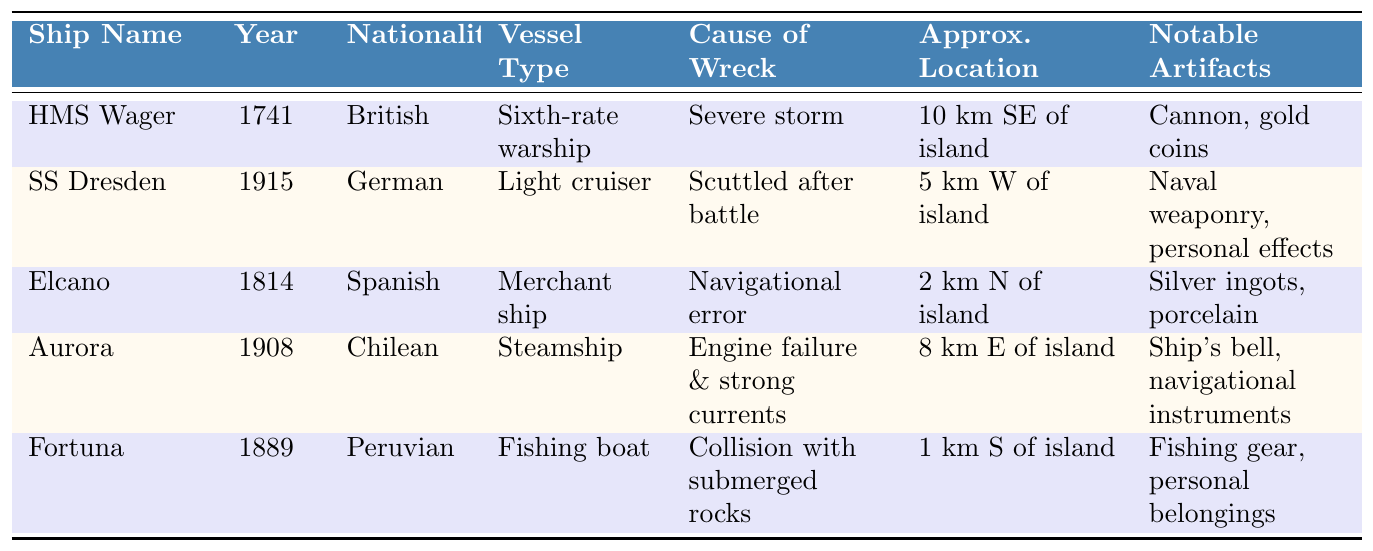What is the nationality of HMS Wager? HMS Wager is listed in the table, and under the "Nationality" column, it states "British."
Answer: British In which year did the SS Dresden sink? Looking at the table, the "Year of Wreck" column for SS Dresden indicates 1915.
Answer: 1915 What caused the wreck of the Aurora? The table shows that the "Cause of Wreck" for the Aurora is "Engine failure and strong currents."
Answer: Engine failure and strong currents Which shipwreck occurred closest to Alejandro Selkirk Island? By checking the "Approximate Location" column, Fortuna is noted as being wrecked 1 km south of the island, which is the nearest distance.
Answer: Fortuna What notable artifacts were found from the ship Elcano? The table indicates that "Silver ingots, porcelain" were notable artifacts found from Elcano.
Answer: Silver ingots, porcelain How many shipwrecks listed in the table occurred in the 19th century? The table identifies three shipwrecks occurring between 1800 and 1899: Elcano (1814), Fortuna (1889), and Aurora (1908 is in the 20th century). Thus, there are three shipwrecks in the 19th century.
Answer: Three Which ship was scuttled after a battle? SS Dresden is specified in the table with the cause of wreck being "Scuttled after battle."
Answer: SS Dresden Is there any German shipwreck listed in the table? Reviewing the table, the SS Dresden is noted as a German shipwreck, confirming the presence of a German vessel.
Answer: Yes What is the average year of wreck for the vessels listed? To find the average, sum the years of wreck (1741 + 1915 + 1814 + 1908 + 1889 = 9185), and divide by the number of vessels (5). The average year is 9185 / 5 = 1837.
Answer: 1837 List all types of vessels represented in the table. The table categorizes the vessels into: Sixth-rate warship, Light cruiser, Merchant ship, Steamship, and Fishing boat. Combining these categories gives the comprehensive answer to the question.
Answer: Sixth-rate warship, Light cruiser, Merchant ship, Steamship, Fishing boat How many ships were wrecked due to natural causes versus man-made causes? Analyzing the causes, HMS Wager (severe storm) and Aurora (engine failure and strong currents) were natural, while SS Dresden (scuttled after battle), Elcano (navigational error), and Fortuna (collision) were man-made. There are two natural and three man-made causes, giving a result of two natural and three man-made shipwrecks.
Answer: 2 natural, 3 man-made 